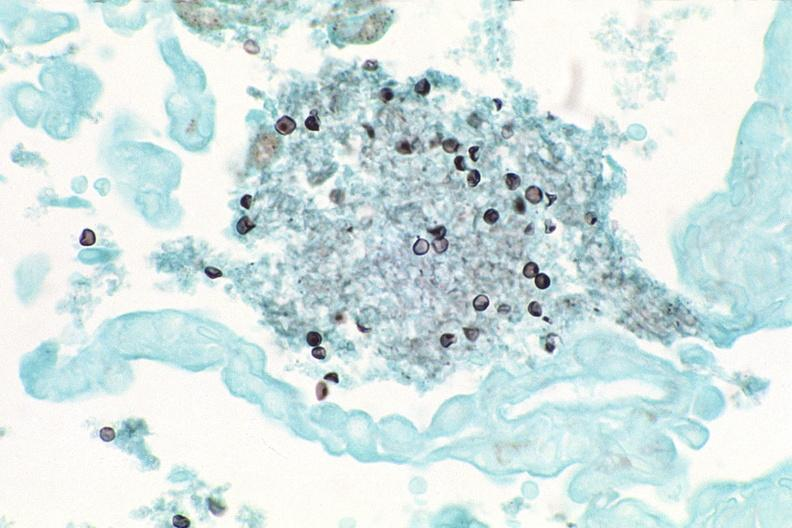s fibroma present?
Answer the question using a single word or phrase. No 